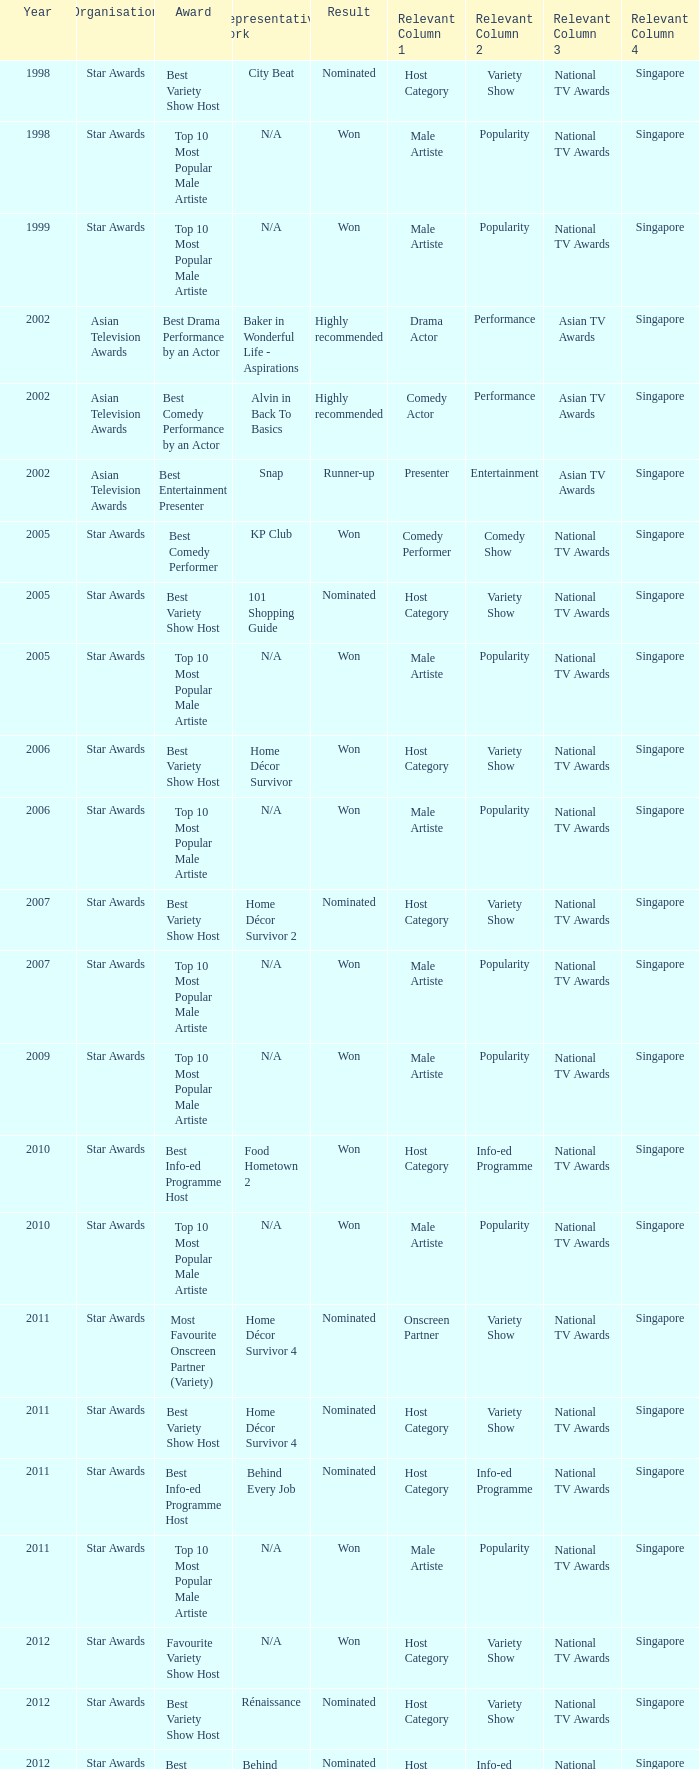What is the organisation in 2011 that was nominated and the award of best info-ed programme host? Star Awards. 